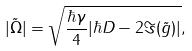Convert formula to latex. <formula><loc_0><loc_0><loc_500><loc_500>| \tilde { \Omega } | = \sqrt { \frac { \hbar { \gamma } } { 4 } | \hbar { D } - 2 \Im ( \tilde { g } ) | } ,</formula> 